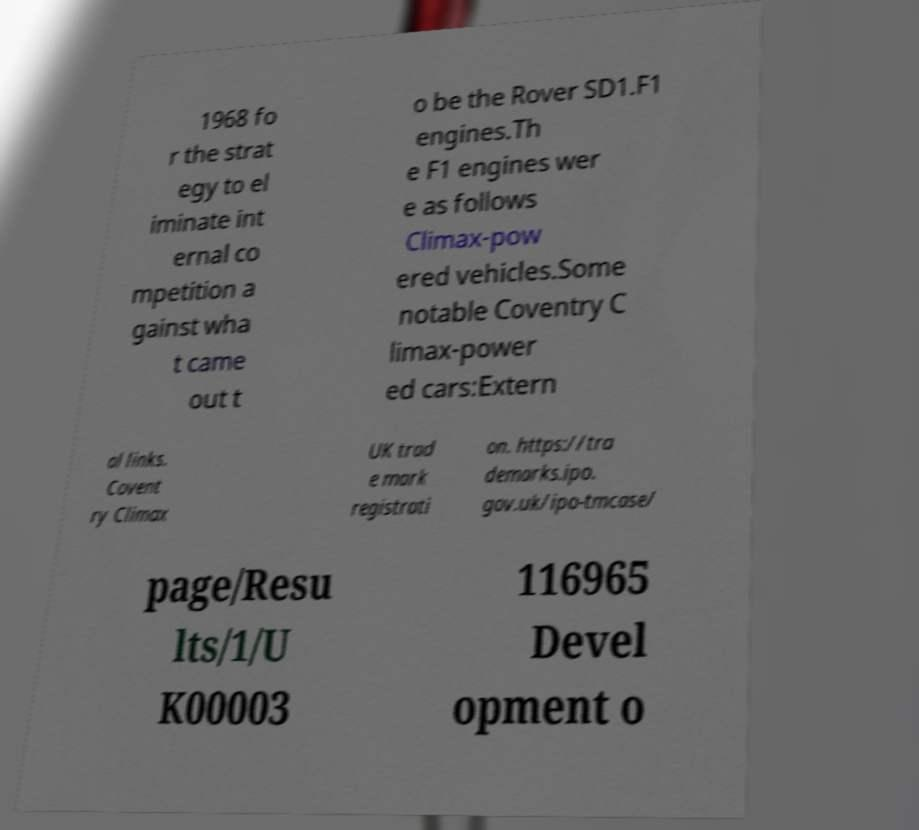I need the written content from this picture converted into text. Can you do that? 1968 fo r the strat egy to el iminate int ernal co mpetition a gainst wha t came out t o be the Rover SD1.F1 engines.Th e F1 engines wer e as follows Climax-pow ered vehicles.Some notable Coventry C limax-power ed cars:Extern al links. Covent ry Climax UK trad e mark registrati on. https://tra demarks.ipo. gov.uk/ipo-tmcase/ page/Resu lts/1/U K00003 116965 Devel opment o 